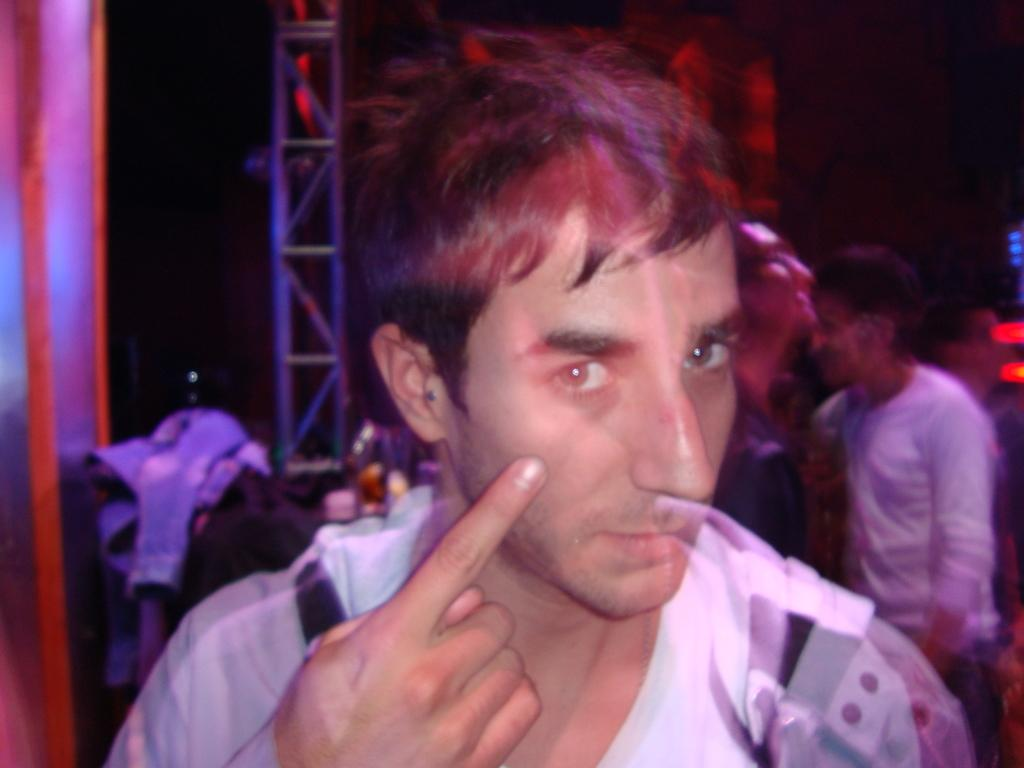What is the main subject of the image? There is a person standing in the image. What is the person wearing? The person is wearing a black shirt. Can you describe the background of the image? There are other persons standing in the background of the image, and there is a railing visible. What type of wing can be seen on the person in the image? There is no wing visible on the person in the image. What type of vest is the person wearing in the image? The person is not wearing a vest in the image; they are wearing a black shirt. 